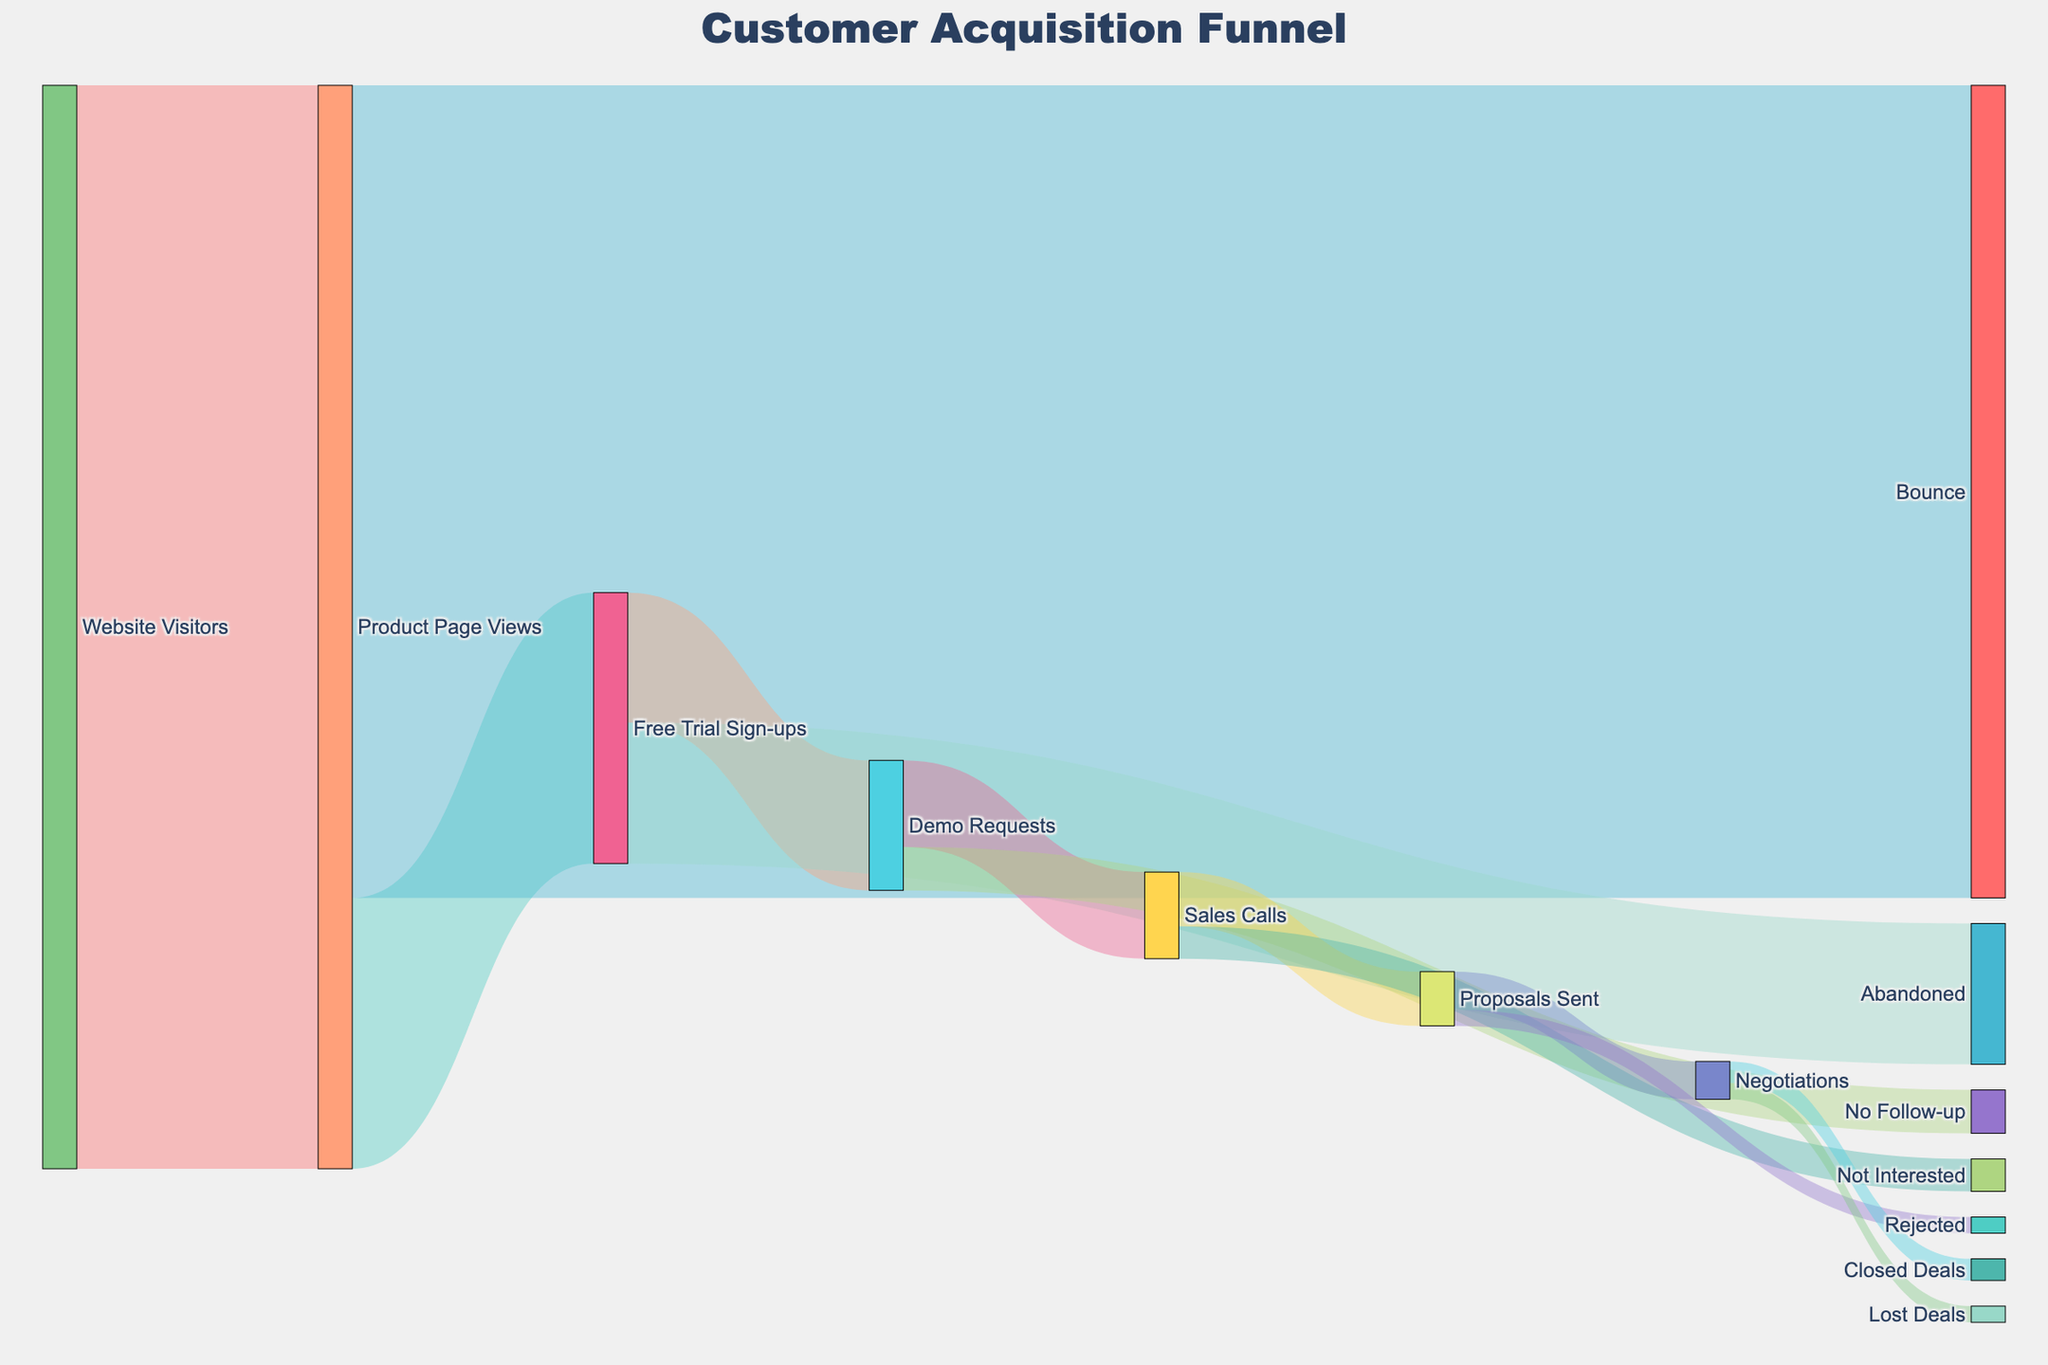What is the title of the Sankey diagram? The title is located at the top of the diagram. It should be clearly visible in large font.
Answer: Customer Acquisition Funnel How many Website Visitors moved on to Product Page Views? Locate the flow from Website Visitors to Product Page Views. The value of this flow represents the number of Website Visitors that moved on.
Answer: 10,000 What is the total number of Free Trial Sign-ups? Add the flows from Product Page Views to Free Trial Sign-ups. The value indicates the number of Free Trial Sign-ups.
Answer: 2,500 What is the difference between the number of Product Page Views and the number of Bounces? Subtract the number of Bounces from the number of Product Page Views.
Answer: 2,500 What percentage of Demo Requests resulted in Sales Calls? Divide the number of Sales Calls by the number of Demo Requests and multiply by 100.
Answer: 66.67% Which stage has the highest number of losses? Look for the stage with the highest value for flows leading to lost opportunities (e.g., Bounce, Abandoned, No Follow-up, Rejected).
Answer: Bounce What is the ratio of Proposals Sent that led to a Closed Deal? Divide the number of Closed Deals by the number of Proposals Sent.
Answer: 200/500 or 0.4 How many leads drop off at the Abandoned stage? Locate the flow from Free Trial Sign-ups to Abandoned. The value of this flow represents the number of leads that drop off.
Answer: 1,300 Which stage has the lowest conversion rate from its previous stage? Calculate the conversion rate for each stage (value of current stage divided by value of previous stage), and find the minimum ratio.
Answer: Abandoned (52%) What is the total flow value starting from Demo Requests? Sum the flows that originate from Demo Requests.
Answer: 1,200 